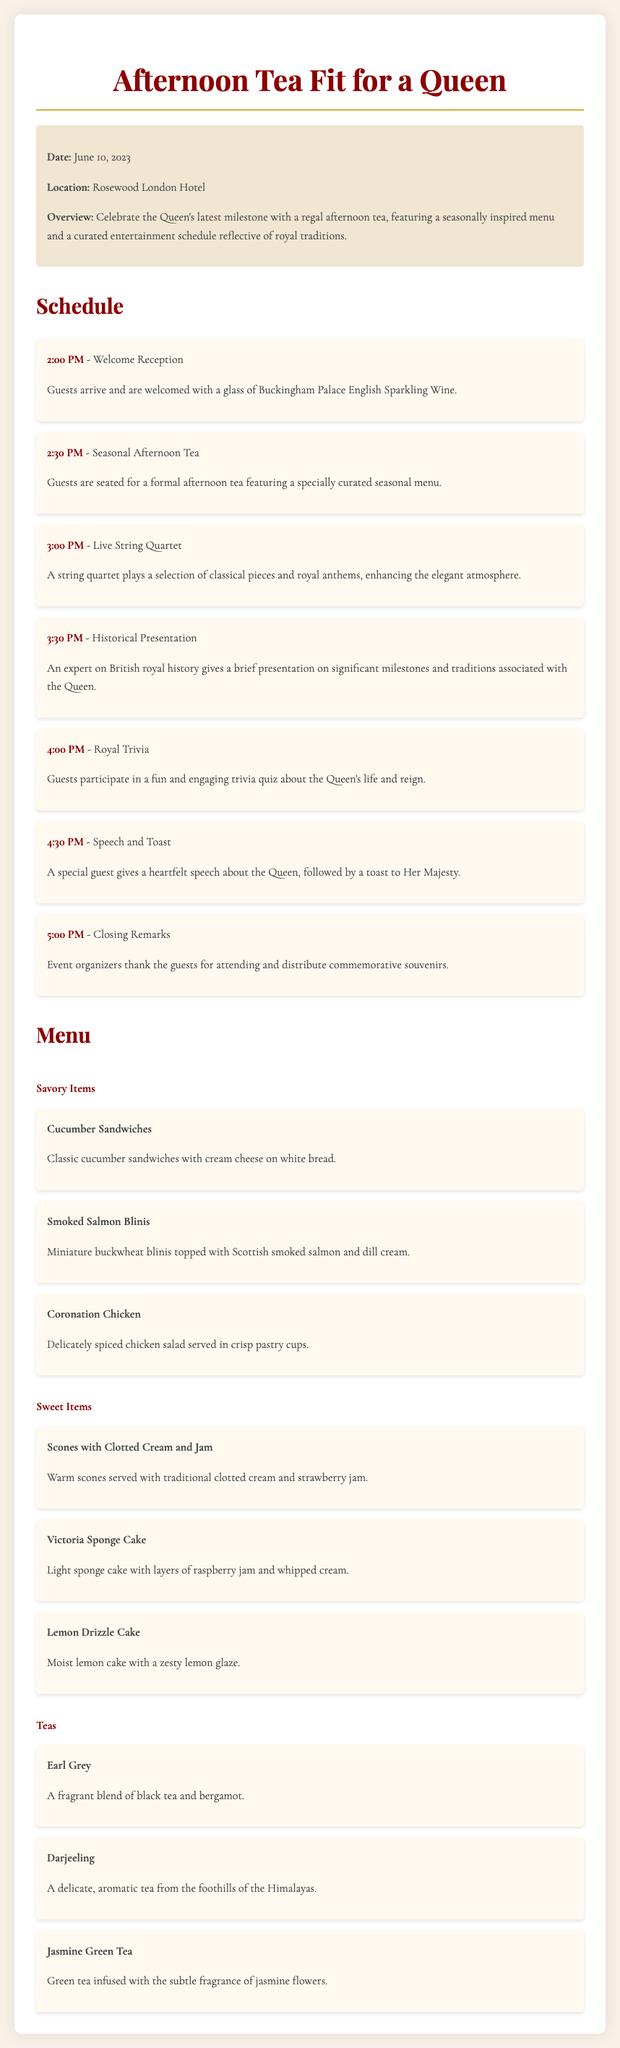What is the date of the event? The date of the event is explicitly mentioned in the event information section of the document.
Answer: June 10, 2023 Where is the event located? The location of the event is specified in the event information section.
Answer: Rosewood London Hotel What is the first activity listed in the schedule? The first activity in the schedule is where guests are welcomed upon arrival.
Answer: Welcome Reception What time does the Royal Trivia start? The schedule provides the exact time for the Royal Trivia activity.
Answer: 4:00 PM What type of tea is Earl Grey? The document describes Earl Grey as a specific blend of tea in the menu section.
Answer: A fragrant blend of black tea and bergamot Which sweet item contains raspberry jam? The menu details the sweet items, including specific ingredients in each item.
Answer: Victoria Sponge Cake How many savory items are listed on the menu? The menu categorizes items, allowing us to count the savory items listed.
Answer: Three What type of entertainment is featured at 3:00 PM? The schedule provides information about the type of entertainment during that time slot.
Answer: Live String Quartet Who gives a speech during the event? The schedule indicates that a special guest will give a speech, but does not name who that is.
Answer: A special guest 